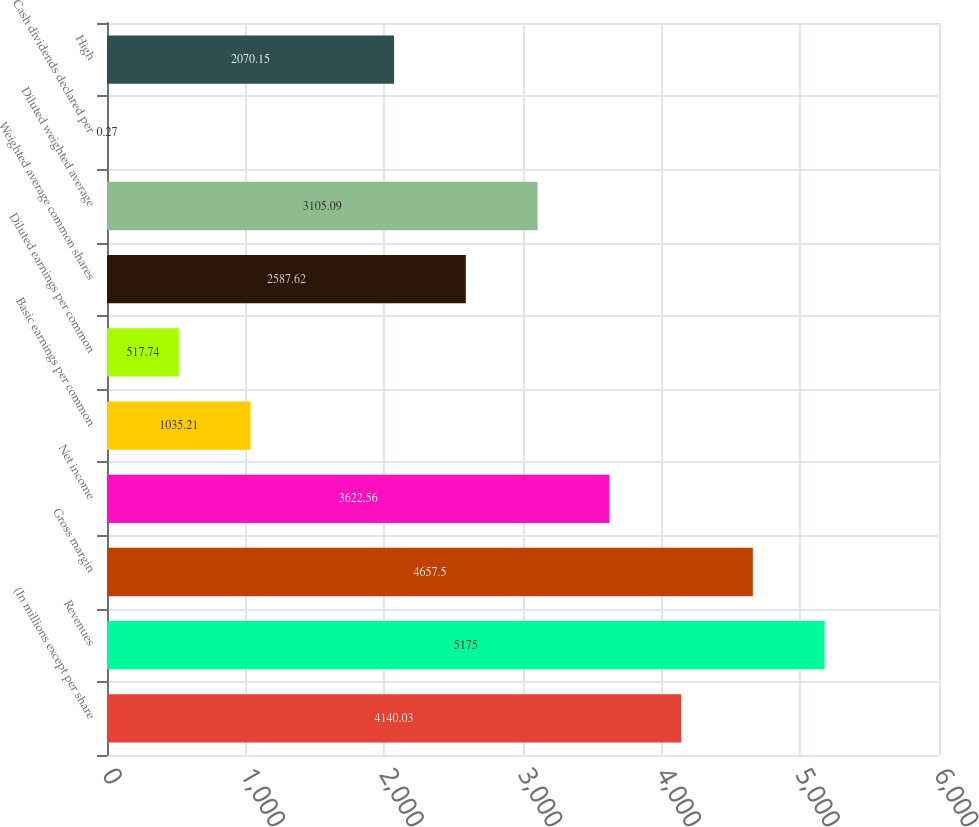Convert chart. <chart><loc_0><loc_0><loc_500><loc_500><bar_chart><fcel>(In millions except per share<fcel>Revenues<fcel>Gross margin<fcel>Net income<fcel>Basic earnings per common<fcel>Diluted earnings per common<fcel>Weighted average common shares<fcel>Diluted weighted average<fcel>Cash dividends declared per<fcel>High<nl><fcel>4140.03<fcel>5175<fcel>4657.5<fcel>3622.56<fcel>1035.21<fcel>517.74<fcel>2587.62<fcel>3105.09<fcel>0.27<fcel>2070.15<nl></chart> 